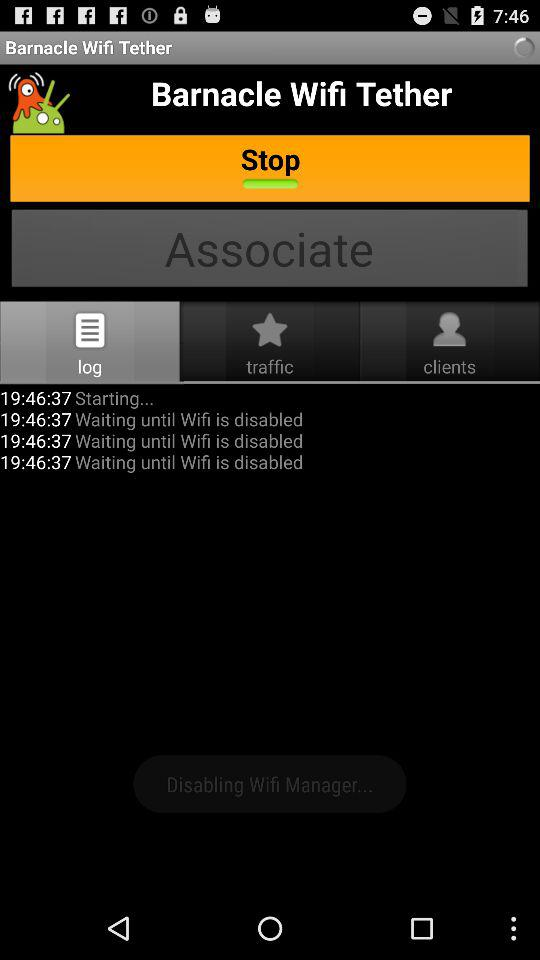Which tab is selected? The selected tab is "log". 